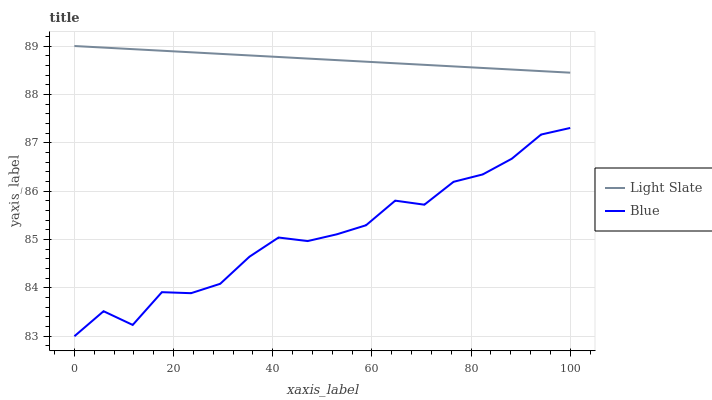Does Blue have the minimum area under the curve?
Answer yes or no. Yes. Does Blue have the maximum area under the curve?
Answer yes or no. No. Is Blue the smoothest?
Answer yes or no. No. Does Blue have the highest value?
Answer yes or no. No. Is Blue less than Light Slate?
Answer yes or no. Yes. Is Light Slate greater than Blue?
Answer yes or no. Yes. Does Blue intersect Light Slate?
Answer yes or no. No. 